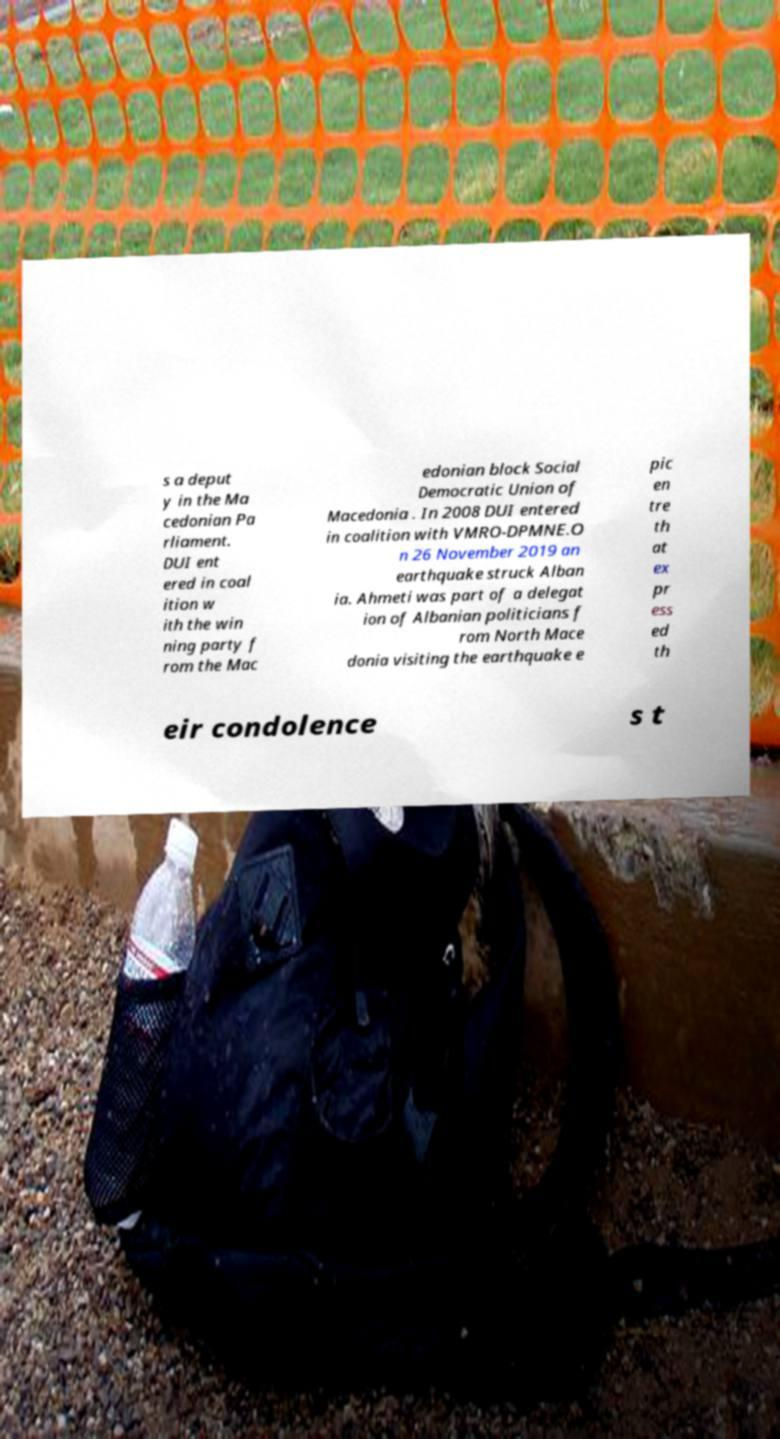Please read and relay the text visible in this image. What does it say? s a deput y in the Ma cedonian Pa rliament. DUI ent ered in coal ition w ith the win ning party f rom the Mac edonian block Social Democratic Union of Macedonia . In 2008 DUI entered in coalition with VMRO-DPMNE.O n 26 November 2019 an earthquake struck Alban ia. Ahmeti was part of a delegat ion of Albanian politicians f rom North Mace donia visiting the earthquake e pic en tre th at ex pr ess ed th eir condolence s t 